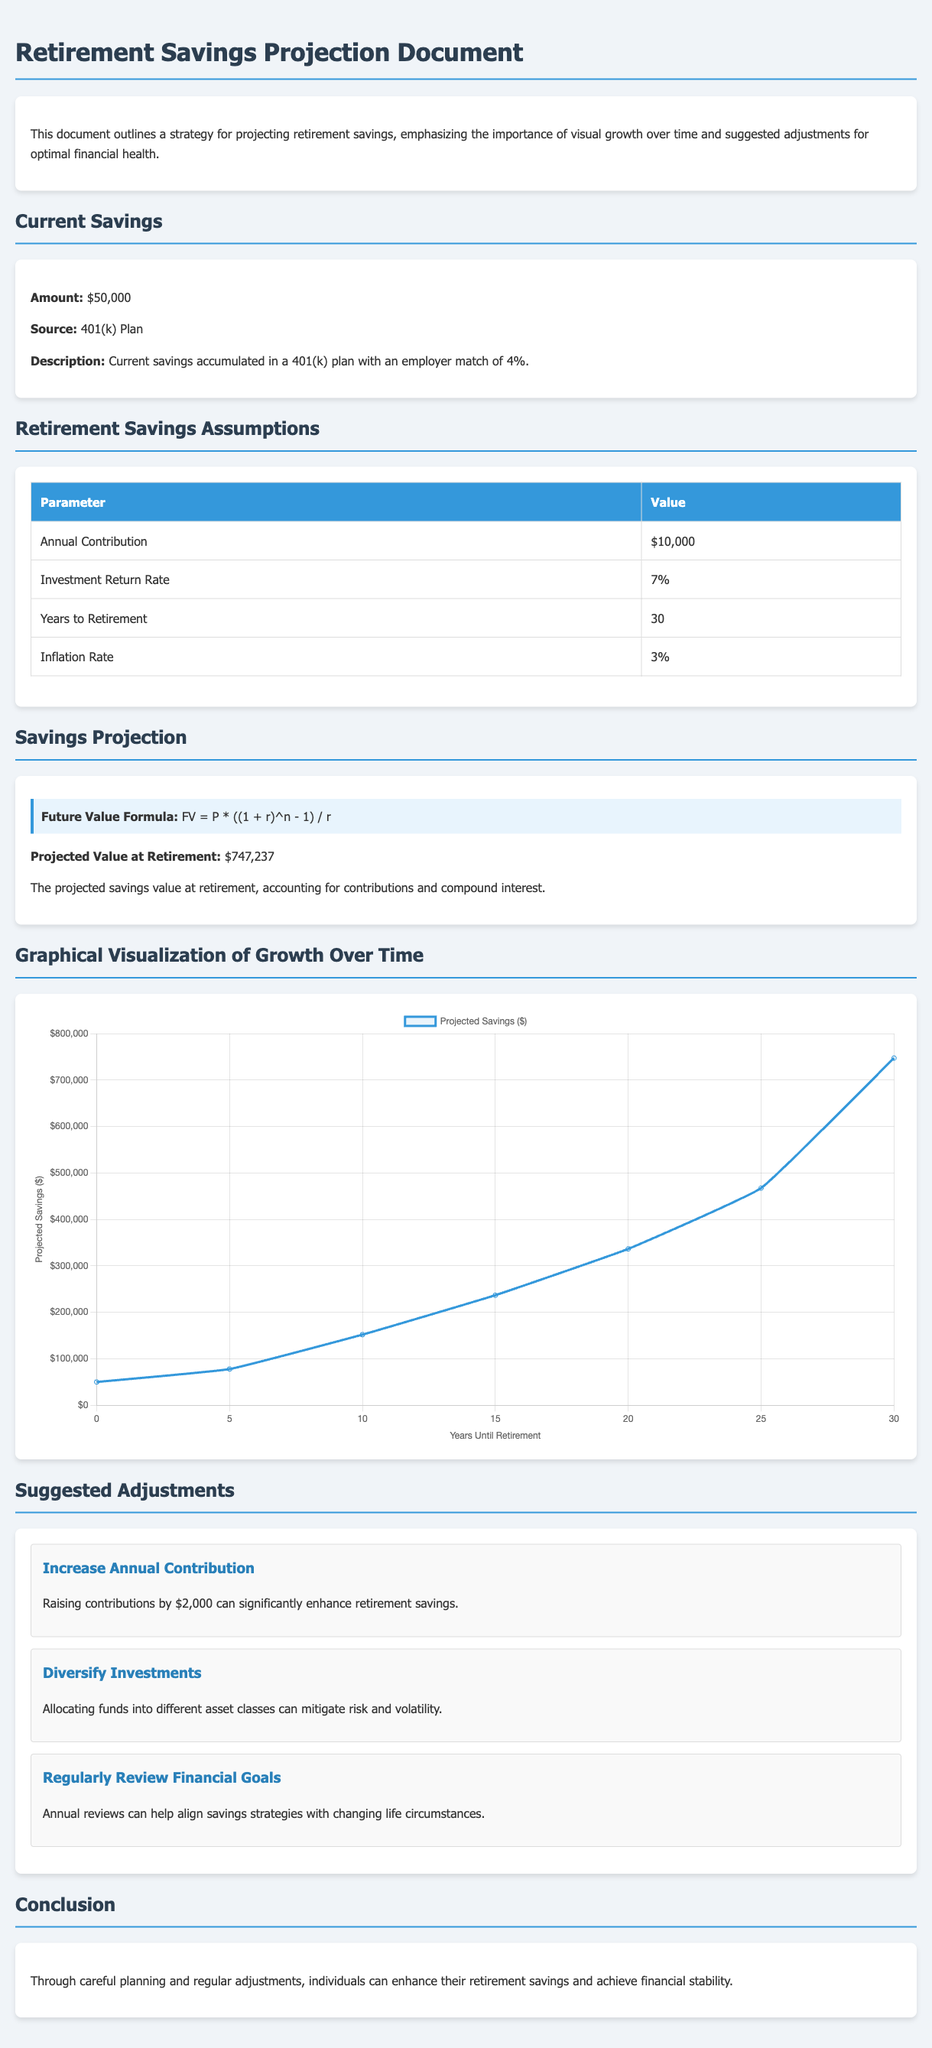What is the current savings amount? The current savings amount is explicitly stated under "Current Savings" in the document.
Answer: $50,000 What is the annual contribution amount? The annual contribution amount is listed in the "Retirement Savings Assumptions" table.
Answer: $10,000 What is the investment return rate? The investment return rate can be found in the "Retirement Savings Assumptions" table of the document.
Answer: 7% What is the projected value at retirement? The projected value at retirement is mentioned in the "Savings Projection" section.
Answer: $747,237 What adjustment is suggested to enhance retirement savings? The suggested adjustments are outlined under "Suggested Adjustments" in the document.
Answer: Increase Annual Contribution How many years until retirement are assumed in the projection? The number of years until retirement is specified in the "Retirement Savings Assumptions" section.
Answer: 30 What is the inflation rate mentioned in the document? The inflation rate is provided in the "Retirement Savings Assumptions" table.
Answer: 3% What formula is used to calculate the future value? The formula is highlighted in the "Savings Projection" section of the document.
Answer: FV = P * ((1 + r)^n - 1) / r What is represented on the x-axis of the chart? The x-axis data is specified in the chart options, indicating what it represents.
Answer: Years Until Retirement 